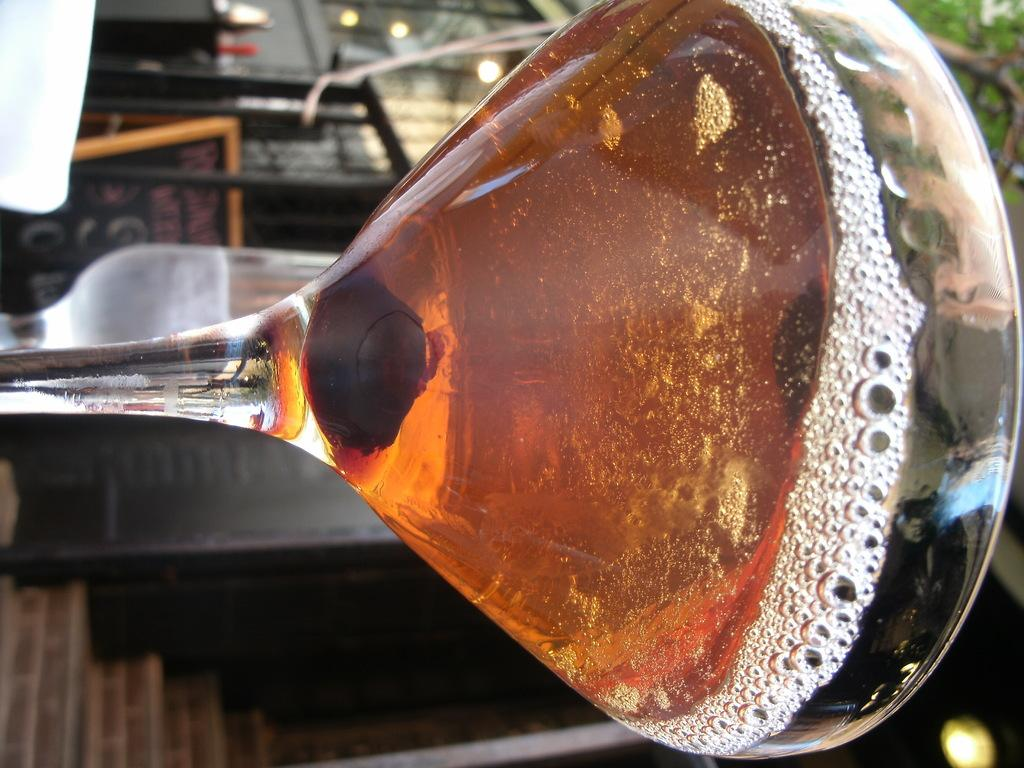What is in the glass that is visible in the image? There is a drink in the glass that is visible in the image. Are there any other glasses in the image? Yes, there is another glass in the background of the image. What can be seen in the image that provides illumination? There are lights visible in the image. What type of natural element is visible in the background of the image? There is a tree in the background of the image. What architectural feature is present in the image? There are steps in the image. What type of surface is present in the image? There is a platform in the image. How would you describe the perspective of the background in the image? The background appears to be buried or have a ground-level view. How many cherries are floating in the soda in the image? There is no soda present in the image, and therefore, no cherries floating in it. 